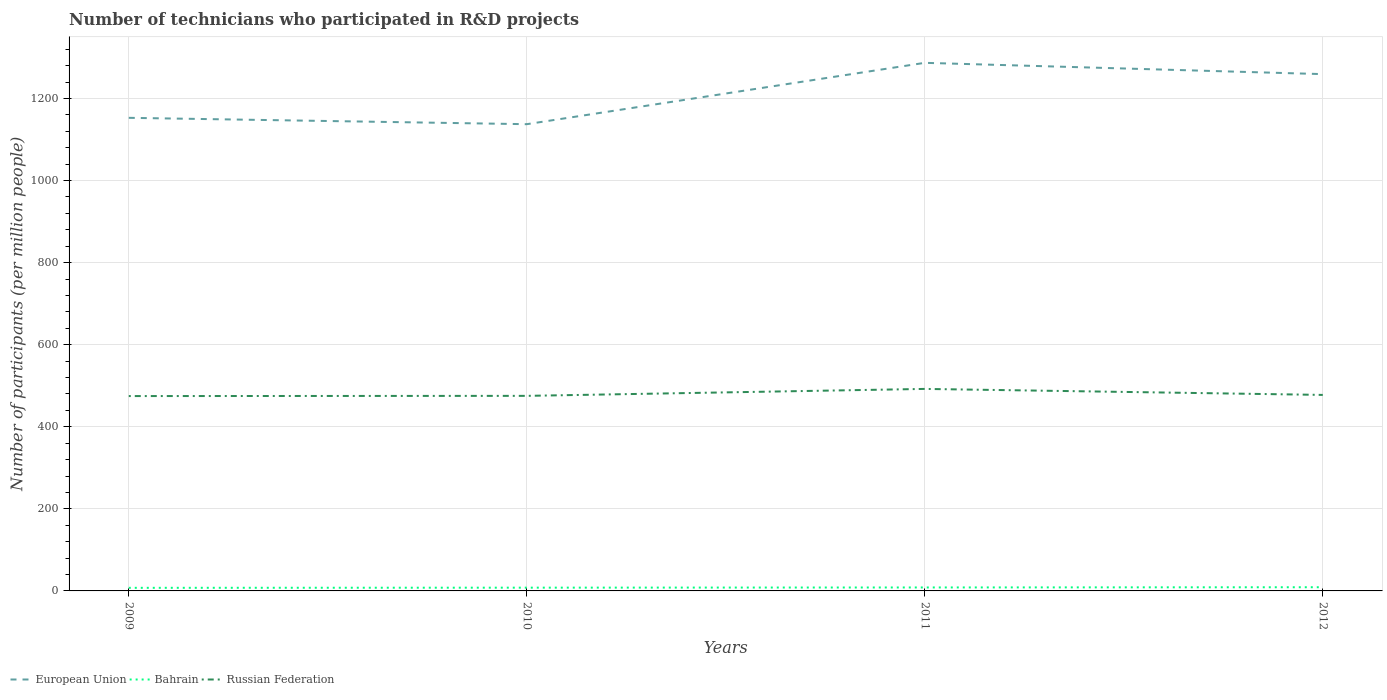Does the line corresponding to Bahrain intersect with the line corresponding to European Union?
Provide a succinct answer. No. Is the number of lines equal to the number of legend labels?
Your response must be concise. Yes. Across all years, what is the maximum number of technicians who participated in R&D projects in Bahrain?
Ensure brevity in your answer.  7.52. In which year was the number of technicians who participated in R&D projects in Russian Federation maximum?
Make the answer very short. 2009. What is the total number of technicians who participated in R&D projects in Bahrain in the graph?
Give a very brief answer. -0.9. What is the difference between the highest and the second highest number of technicians who participated in R&D projects in Bahrain?
Your answer should be compact. 1.48. How many lines are there?
Provide a succinct answer. 3. What is the difference between two consecutive major ticks on the Y-axis?
Give a very brief answer. 200. Are the values on the major ticks of Y-axis written in scientific E-notation?
Provide a short and direct response. No. Does the graph contain any zero values?
Your answer should be compact. No. Where does the legend appear in the graph?
Your response must be concise. Bottom left. How are the legend labels stacked?
Provide a succinct answer. Horizontal. What is the title of the graph?
Your response must be concise. Number of technicians who participated in R&D projects. Does "Japan" appear as one of the legend labels in the graph?
Offer a terse response. No. What is the label or title of the Y-axis?
Your answer should be compact. Number of participants (per million people). What is the Number of participants (per million people) of European Union in 2009?
Your answer should be compact. 1152.73. What is the Number of participants (per million people) in Bahrain in 2009?
Your answer should be very brief. 7.52. What is the Number of participants (per million people) of Russian Federation in 2009?
Keep it short and to the point. 474.78. What is the Number of participants (per million people) of European Union in 2010?
Make the answer very short. 1137.23. What is the Number of participants (per million people) of Bahrain in 2010?
Make the answer very short. 7.93. What is the Number of participants (per million people) in Russian Federation in 2010?
Offer a very short reply. 475.29. What is the Number of participants (per million people) in European Union in 2011?
Keep it short and to the point. 1286.74. What is the Number of participants (per million people) of Bahrain in 2011?
Keep it short and to the point. 8.42. What is the Number of participants (per million people) of Russian Federation in 2011?
Offer a terse response. 492.22. What is the Number of participants (per million people) in European Union in 2012?
Provide a short and direct response. 1259.21. What is the Number of participants (per million people) of Bahrain in 2012?
Keep it short and to the point. 9. What is the Number of participants (per million people) in Russian Federation in 2012?
Your answer should be very brief. 477.59. Across all years, what is the maximum Number of participants (per million people) of European Union?
Ensure brevity in your answer.  1286.74. Across all years, what is the maximum Number of participants (per million people) in Bahrain?
Keep it short and to the point. 9. Across all years, what is the maximum Number of participants (per million people) in Russian Federation?
Your answer should be very brief. 492.22. Across all years, what is the minimum Number of participants (per million people) in European Union?
Provide a succinct answer. 1137.23. Across all years, what is the minimum Number of participants (per million people) in Bahrain?
Your response must be concise. 7.52. Across all years, what is the minimum Number of participants (per million people) in Russian Federation?
Your answer should be very brief. 474.78. What is the total Number of participants (per million people) in European Union in the graph?
Your answer should be very brief. 4835.91. What is the total Number of participants (per million people) in Bahrain in the graph?
Your answer should be very brief. 32.87. What is the total Number of participants (per million people) in Russian Federation in the graph?
Give a very brief answer. 1919.87. What is the difference between the Number of participants (per million people) of European Union in 2009 and that in 2010?
Provide a short and direct response. 15.51. What is the difference between the Number of participants (per million people) in Bahrain in 2009 and that in 2010?
Make the answer very short. -0.41. What is the difference between the Number of participants (per million people) of Russian Federation in 2009 and that in 2010?
Your answer should be very brief. -0.52. What is the difference between the Number of participants (per million people) of European Union in 2009 and that in 2011?
Ensure brevity in your answer.  -134.01. What is the difference between the Number of participants (per million people) of Bahrain in 2009 and that in 2011?
Ensure brevity in your answer.  -0.9. What is the difference between the Number of participants (per million people) of Russian Federation in 2009 and that in 2011?
Offer a terse response. -17.44. What is the difference between the Number of participants (per million people) of European Union in 2009 and that in 2012?
Give a very brief answer. -106.47. What is the difference between the Number of participants (per million people) of Bahrain in 2009 and that in 2012?
Your answer should be compact. -1.48. What is the difference between the Number of participants (per million people) in Russian Federation in 2009 and that in 2012?
Provide a succinct answer. -2.81. What is the difference between the Number of participants (per million people) of European Union in 2010 and that in 2011?
Your answer should be compact. -149.52. What is the difference between the Number of participants (per million people) in Bahrain in 2010 and that in 2011?
Ensure brevity in your answer.  -0.49. What is the difference between the Number of participants (per million people) in Russian Federation in 2010 and that in 2011?
Offer a very short reply. -16.92. What is the difference between the Number of participants (per million people) in European Union in 2010 and that in 2012?
Your response must be concise. -121.98. What is the difference between the Number of participants (per million people) of Bahrain in 2010 and that in 2012?
Offer a very short reply. -1.07. What is the difference between the Number of participants (per million people) of Russian Federation in 2010 and that in 2012?
Provide a short and direct response. -2.29. What is the difference between the Number of participants (per million people) in European Union in 2011 and that in 2012?
Your response must be concise. 27.54. What is the difference between the Number of participants (per million people) of Bahrain in 2011 and that in 2012?
Keep it short and to the point. -0.58. What is the difference between the Number of participants (per million people) in Russian Federation in 2011 and that in 2012?
Provide a succinct answer. 14.63. What is the difference between the Number of participants (per million people) of European Union in 2009 and the Number of participants (per million people) of Bahrain in 2010?
Ensure brevity in your answer.  1144.8. What is the difference between the Number of participants (per million people) of European Union in 2009 and the Number of participants (per million people) of Russian Federation in 2010?
Your response must be concise. 677.44. What is the difference between the Number of participants (per million people) in Bahrain in 2009 and the Number of participants (per million people) in Russian Federation in 2010?
Keep it short and to the point. -467.77. What is the difference between the Number of participants (per million people) of European Union in 2009 and the Number of participants (per million people) of Bahrain in 2011?
Your answer should be very brief. 1144.31. What is the difference between the Number of participants (per million people) in European Union in 2009 and the Number of participants (per million people) in Russian Federation in 2011?
Offer a very short reply. 660.52. What is the difference between the Number of participants (per million people) in Bahrain in 2009 and the Number of participants (per million people) in Russian Federation in 2011?
Your response must be concise. -484.7. What is the difference between the Number of participants (per million people) in European Union in 2009 and the Number of participants (per million people) in Bahrain in 2012?
Your answer should be compact. 1143.73. What is the difference between the Number of participants (per million people) of European Union in 2009 and the Number of participants (per million people) of Russian Federation in 2012?
Ensure brevity in your answer.  675.15. What is the difference between the Number of participants (per million people) of Bahrain in 2009 and the Number of participants (per million people) of Russian Federation in 2012?
Make the answer very short. -470.06. What is the difference between the Number of participants (per million people) in European Union in 2010 and the Number of participants (per million people) in Bahrain in 2011?
Offer a terse response. 1128.8. What is the difference between the Number of participants (per million people) in European Union in 2010 and the Number of participants (per million people) in Russian Federation in 2011?
Offer a terse response. 645.01. What is the difference between the Number of participants (per million people) in Bahrain in 2010 and the Number of participants (per million people) in Russian Federation in 2011?
Give a very brief answer. -484.29. What is the difference between the Number of participants (per million people) in European Union in 2010 and the Number of participants (per million people) in Bahrain in 2012?
Keep it short and to the point. 1128.23. What is the difference between the Number of participants (per million people) in European Union in 2010 and the Number of participants (per million people) in Russian Federation in 2012?
Make the answer very short. 659.64. What is the difference between the Number of participants (per million people) of Bahrain in 2010 and the Number of participants (per million people) of Russian Federation in 2012?
Provide a short and direct response. -469.66. What is the difference between the Number of participants (per million people) of European Union in 2011 and the Number of participants (per million people) of Bahrain in 2012?
Ensure brevity in your answer.  1277.75. What is the difference between the Number of participants (per million people) in European Union in 2011 and the Number of participants (per million people) in Russian Federation in 2012?
Offer a very short reply. 809.16. What is the difference between the Number of participants (per million people) of Bahrain in 2011 and the Number of participants (per million people) of Russian Federation in 2012?
Provide a succinct answer. -469.16. What is the average Number of participants (per million people) of European Union per year?
Make the answer very short. 1208.98. What is the average Number of participants (per million people) of Bahrain per year?
Offer a terse response. 8.22. What is the average Number of participants (per million people) of Russian Federation per year?
Your answer should be compact. 479.97. In the year 2009, what is the difference between the Number of participants (per million people) of European Union and Number of participants (per million people) of Bahrain?
Ensure brevity in your answer.  1145.21. In the year 2009, what is the difference between the Number of participants (per million people) in European Union and Number of participants (per million people) in Russian Federation?
Provide a succinct answer. 677.96. In the year 2009, what is the difference between the Number of participants (per million people) in Bahrain and Number of participants (per million people) in Russian Federation?
Provide a short and direct response. -467.26. In the year 2010, what is the difference between the Number of participants (per million people) of European Union and Number of participants (per million people) of Bahrain?
Ensure brevity in your answer.  1129.3. In the year 2010, what is the difference between the Number of participants (per million people) in European Union and Number of participants (per million people) in Russian Federation?
Your answer should be compact. 661.93. In the year 2010, what is the difference between the Number of participants (per million people) in Bahrain and Number of participants (per million people) in Russian Federation?
Keep it short and to the point. -467.36. In the year 2011, what is the difference between the Number of participants (per million people) in European Union and Number of participants (per million people) in Bahrain?
Ensure brevity in your answer.  1278.32. In the year 2011, what is the difference between the Number of participants (per million people) of European Union and Number of participants (per million people) of Russian Federation?
Offer a terse response. 794.53. In the year 2011, what is the difference between the Number of participants (per million people) of Bahrain and Number of participants (per million people) of Russian Federation?
Your response must be concise. -483.79. In the year 2012, what is the difference between the Number of participants (per million people) in European Union and Number of participants (per million people) in Bahrain?
Keep it short and to the point. 1250.21. In the year 2012, what is the difference between the Number of participants (per million people) of European Union and Number of participants (per million people) of Russian Federation?
Ensure brevity in your answer.  781.62. In the year 2012, what is the difference between the Number of participants (per million people) of Bahrain and Number of participants (per million people) of Russian Federation?
Your answer should be very brief. -468.59. What is the ratio of the Number of participants (per million people) of European Union in 2009 to that in 2010?
Offer a terse response. 1.01. What is the ratio of the Number of participants (per million people) of Bahrain in 2009 to that in 2010?
Your response must be concise. 0.95. What is the ratio of the Number of participants (per million people) of European Union in 2009 to that in 2011?
Provide a succinct answer. 0.9. What is the ratio of the Number of participants (per million people) in Bahrain in 2009 to that in 2011?
Keep it short and to the point. 0.89. What is the ratio of the Number of participants (per million people) in Russian Federation in 2009 to that in 2011?
Give a very brief answer. 0.96. What is the ratio of the Number of participants (per million people) of European Union in 2009 to that in 2012?
Give a very brief answer. 0.92. What is the ratio of the Number of participants (per million people) of Bahrain in 2009 to that in 2012?
Make the answer very short. 0.84. What is the ratio of the Number of participants (per million people) of European Union in 2010 to that in 2011?
Your answer should be very brief. 0.88. What is the ratio of the Number of participants (per million people) in Bahrain in 2010 to that in 2011?
Ensure brevity in your answer.  0.94. What is the ratio of the Number of participants (per million people) in Russian Federation in 2010 to that in 2011?
Make the answer very short. 0.97. What is the ratio of the Number of participants (per million people) in European Union in 2010 to that in 2012?
Offer a terse response. 0.9. What is the ratio of the Number of participants (per million people) in Bahrain in 2010 to that in 2012?
Your answer should be compact. 0.88. What is the ratio of the Number of participants (per million people) in Russian Federation in 2010 to that in 2012?
Provide a short and direct response. 1. What is the ratio of the Number of participants (per million people) in European Union in 2011 to that in 2012?
Give a very brief answer. 1.02. What is the ratio of the Number of participants (per million people) in Bahrain in 2011 to that in 2012?
Give a very brief answer. 0.94. What is the ratio of the Number of participants (per million people) of Russian Federation in 2011 to that in 2012?
Your response must be concise. 1.03. What is the difference between the highest and the second highest Number of participants (per million people) of European Union?
Make the answer very short. 27.54. What is the difference between the highest and the second highest Number of participants (per million people) of Bahrain?
Your response must be concise. 0.58. What is the difference between the highest and the second highest Number of participants (per million people) in Russian Federation?
Your response must be concise. 14.63. What is the difference between the highest and the lowest Number of participants (per million people) of European Union?
Provide a short and direct response. 149.52. What is the difference between the highest and the lowest Number of participants (per million people) in Bahrain?
Your answer should be very brief. 1.48. What is the difference between the highest and the lowest Number of participants (per million people) of Russian Federation?
Give a very brief answer. 17.44. 